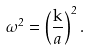Convert formula to latex. <formula><loc_0><loc_0><loc_500><loc_500>\omega ^ { 2 } = \left ( \frac { \mathrm k } { a } \right ) ^ { 2 } .</formula> 